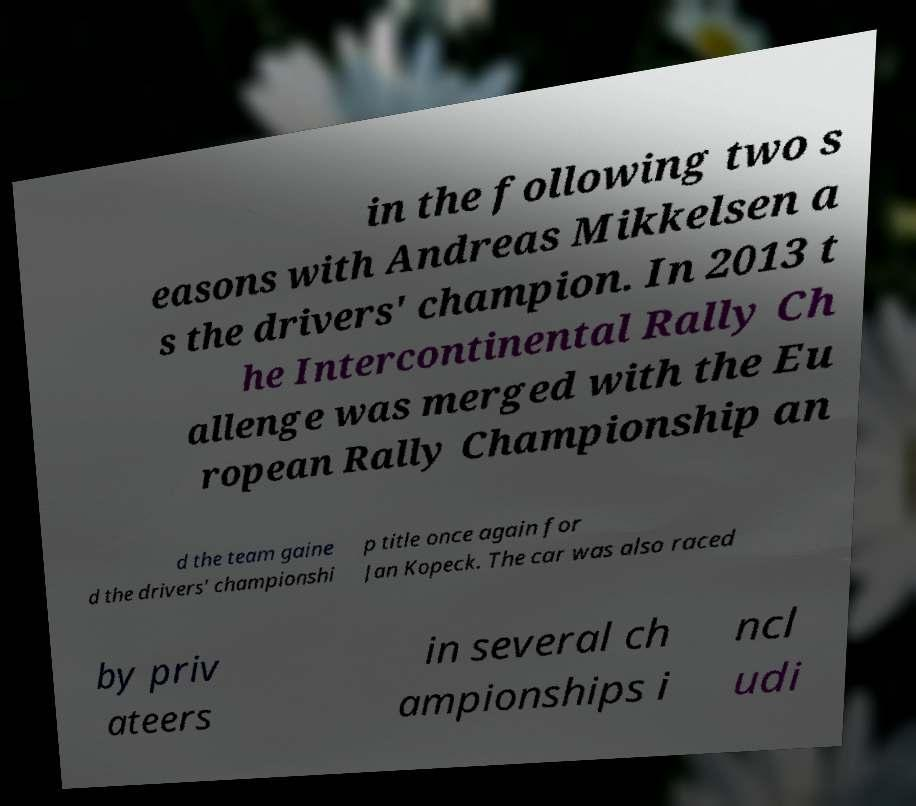What messages or text are displayed in this image? I need them in a readable, typed format. in the following two s easons with Andreas Mikkelsen a s the drivers' champion. In 2013 t he Intercontinental Rally Ch allenge was merged with the Eu ropean Rally Championship an d the team gaine d the drivers' championshi p title once again for Jan Kopeck. The car was also raced by priv ateers in several ch ampionships i ncl udi 